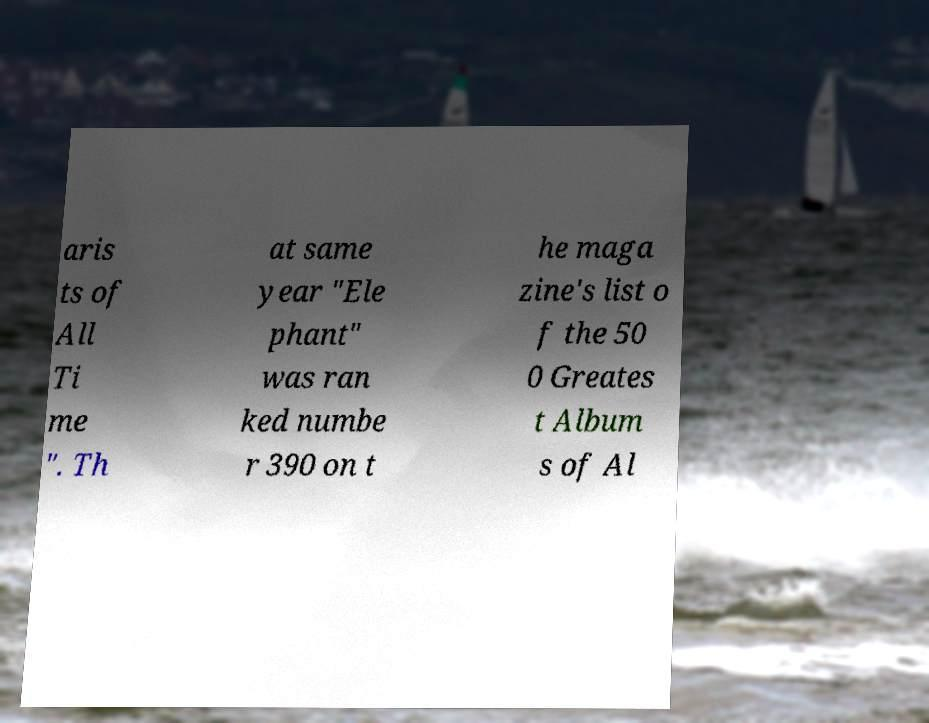What messages or text are displayed in this image? I need them in a readable, typed format. aris ts of All Ti me ". Th at same year "Ele phant" was ran ked numbe r 390 on t he maga zine's list o f the 50 0 Greates t Album s of Al 